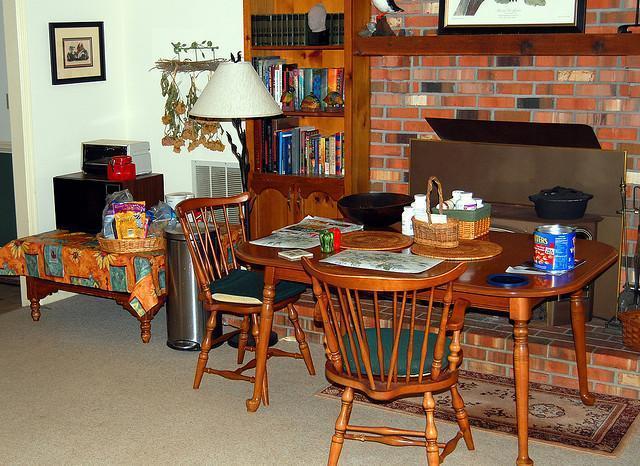How many books are in the picture?
Give a very brief answer. 2. How many chairs are there?
Give a very brief answer. 2. How many elephants are standing near the wall?
Give a very brief answer. 0. 